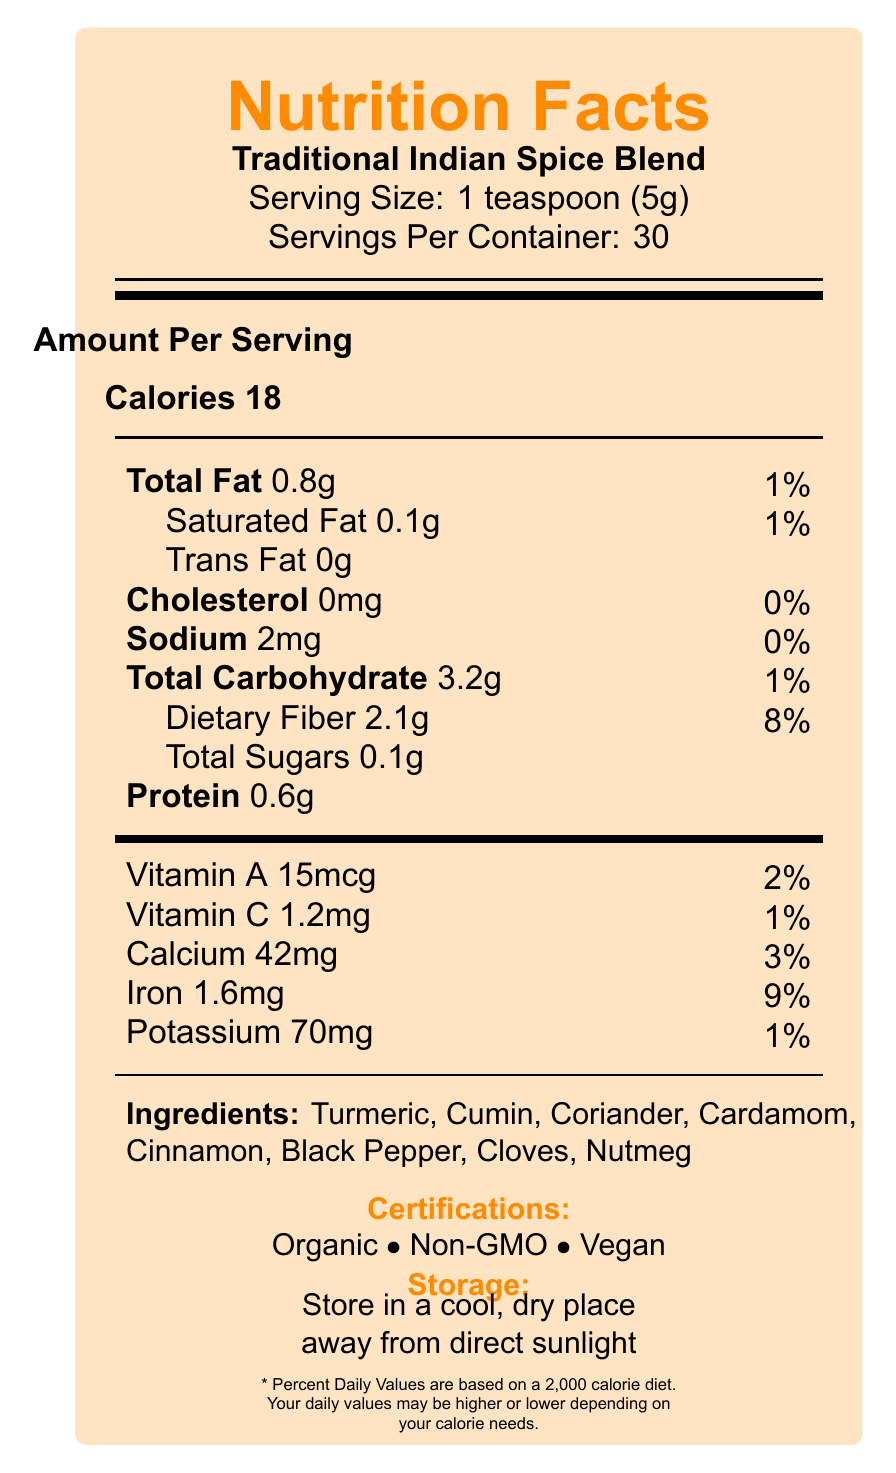what is the serving size of the Traditional Indian Spice Blend? The serving size is clearly stated as 1 teaspoon (5g) in the document.
Answer: 1 teaspoon (5g) how many servings are in each container? The document states that there are 30 servings per container.
Answer: 30 servings how many calories are in one serving of the spice blend? The document lists the calories per serving as 18.
Answer: 18 calories how much dietary fiber is in a single serving, and what is its Daily Value percentage? The document shows that a single serving contains 2.1g of dietary fiber, which is 8% of the daily value.
Answer: 2.1g, 8% list the certifications of the spice blend. The document specifies the certifications as Organic, Non-GMO, and Vegan.
Answer: Organic, Non-GMO, Vegan which spice is known for enhancing nutrient absorption and boosting metabolism? A. Turmeric B. Cumin C. Black Pepper D. Cloves The document mentions that Black Pepper is noted for enhancing nutrient absorption and boosting metabolism.
Answer: C. Black Pepper what is the percentage of the Daily Value for iron in one serving? A. 2% B. 3% C. 8% D. 9% The document cites that one serving contains 9% of the Daily Value for iron.
Answer: D. 9% does the spice blend contain any trans fat? The document shows 0g of trans fat per serving.
Answer: No summarize the main idea of the document. The document is organized to provide comprehensive nutritional information along with the health and beauty benefits of the spices, their certifications, and usage tips.
Answer: The document provides the Nutrition Facts for a Traditional Indian Spice Blend, detailing its serving size, calories, macronutrients, vitamins, minerals, ingredients, health benefits of specific spices, beauty tips, storage instructions, allergen information, and certifications. what is the benefit of using coriander in the spice blend? The document specifies that coriander is rich in antioxidants and may help lower blood sugar levels.
Answer: May help lower blood sugar levels and is rich in antioxidants what are the storage instructions for this spice blend? The document notes that the spice blend should be stored in a cool, dry place away from direct sunlight.
Answer: Store in a cool, dry place away from direct sunlight are there any allergens noted in the spice blend? The document states that the blend may contain traces of mustard seeds.
Answer: May contain traces of mustard seeds how much protein is in one serving? The document shows that there is 0.6g of protein in one serving.
Answer: 0.6g which vitamin is present in larger quantity: Vitamin A or Vitamin C? The document lists Vitamin A as 15mcg (2% DV) and Vitamin C as 1.2mg (1% DV), indicating more Vitamin A.
Answer: Vitamin A what specific DIY beauty tip involves nutmeg? The document includes this specific beauty tip.
Answer: Apply a paste of nutmeg and milk to reduce dark circles under eyes which spice in the blend is noted for its anti-inflammatory and antioxidant properties? The document mentions that turmeric has anti-inflammatory and antioxidant properties.
Answer: Turmeric how much calcium is in a single serving and what is its Daily Value percentage? The document states that one serving contains 42mg of calcium, which is 3% of the daily value.
Answer: 42mg, 3% how much total carbohydrate is in one serving? The document shows that each serving contains 3.2g of total carbohydrate.
Answer: 3.2g how many options are there for beauty tips provided in the document? The document lists four different DIY beauty tips involving the spices in the blend.
Answer: 4 options does the spice blend contain cloves? The document lists cloves as one of the ingredients.
Answer: Yes when should you put the spices in the fridge? The document only specifies storage in a cool, dry place away from direct sunlight but does not mention using a fridge.
Answer: Cannot be determined 